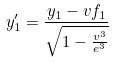<formula> <loc_0><loc_0><loc_500><loc_500>y _ { 1 } ^ { \prime } = \frac { y _ { 1 } - v f _ { 1 } } { \sqrt { 1 - \frac { v ^ { 3 } } { e ^ { 3 } } } }</formula> 